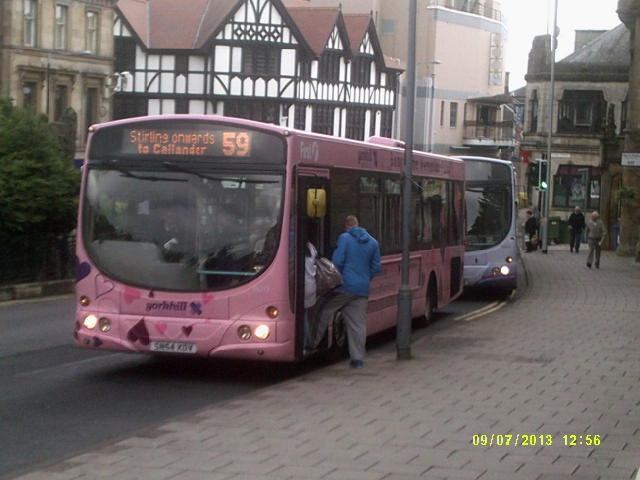Describe the objects in this image and their specific colors. I can see bus in gray, black, and brown tones, bus in gray and black tones, people in gray, black, navy, and darkblue tones, people in gray and black tones, and backpack in gray and black tones in this image. 